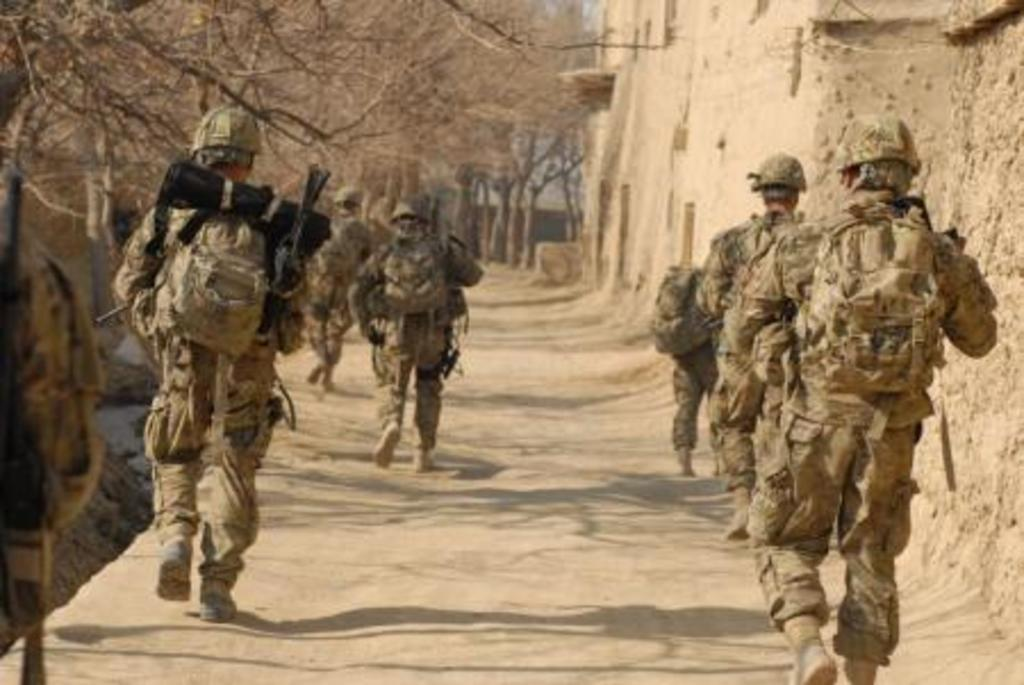What is happening in the image involving the group of people? The people in the image are running. What items are the people wearing while running? The people are wearing backpacks and helmets. What can be seen in the background of the image? There are trees and houses in the background of the image. What type of plants can be seen growing on the cow in the image? There is no cow present in the image, so it is not possible to determine what type of plants might be growing on it. 